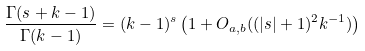<formula> <loc_0><loc_0><loc_500><loc_500>\frac { \Gamma ( s + k - 1 ) } { \Gamma ( k - 1 ) } = ( k - 1 ) ^ { s } \left ( 1 + O _ { a , b } ( ( | s | + 1 ) ^ { 2 } k ^ { - 1 } ) \right )</formula> 